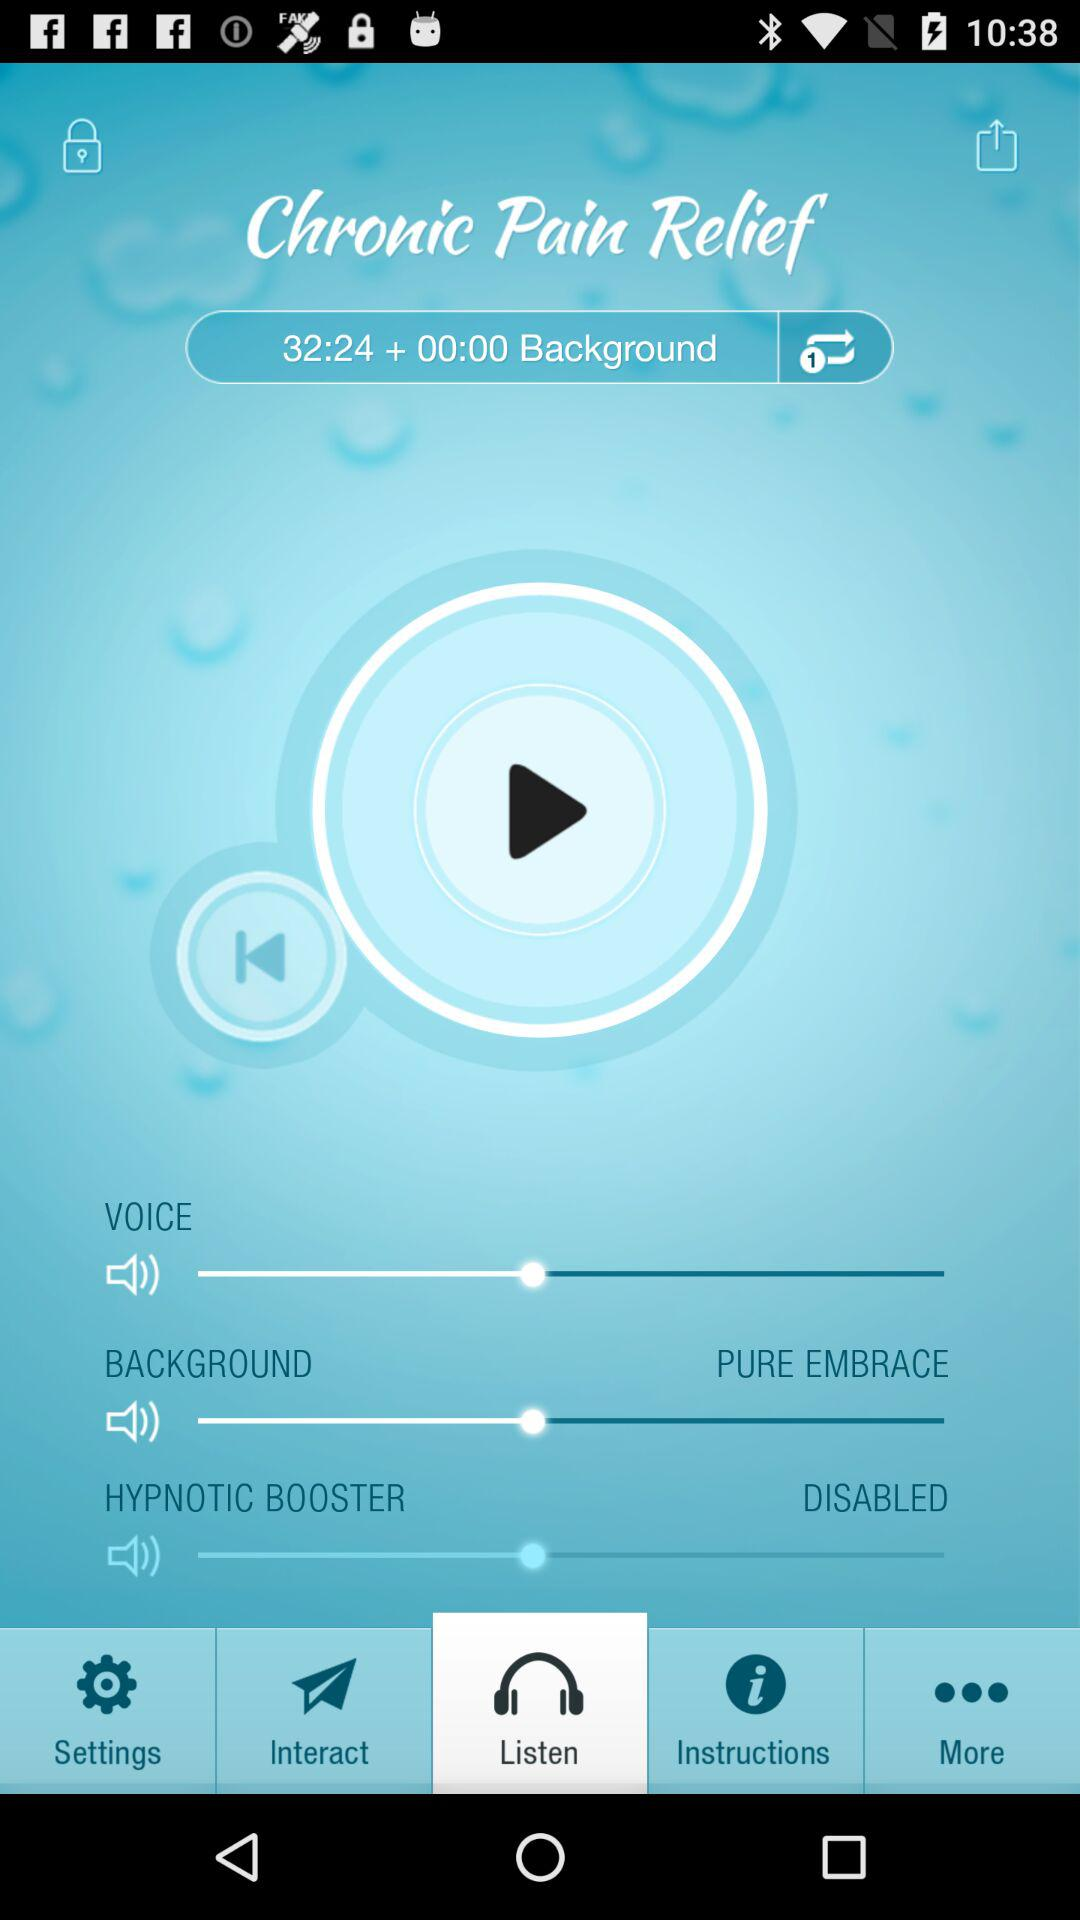Which tab is selected? The selected tab is "Listen". 